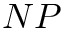Convert formula to latex. <formula><loc_0><loc_0><loc_500><loc_500>N P</formula> 